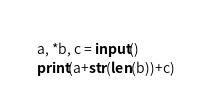<code> <loc_0><loc_0><loc_500><loc_500><_Python_>a, *b, c = input()
print(a+str(len(b))+c)</code> 